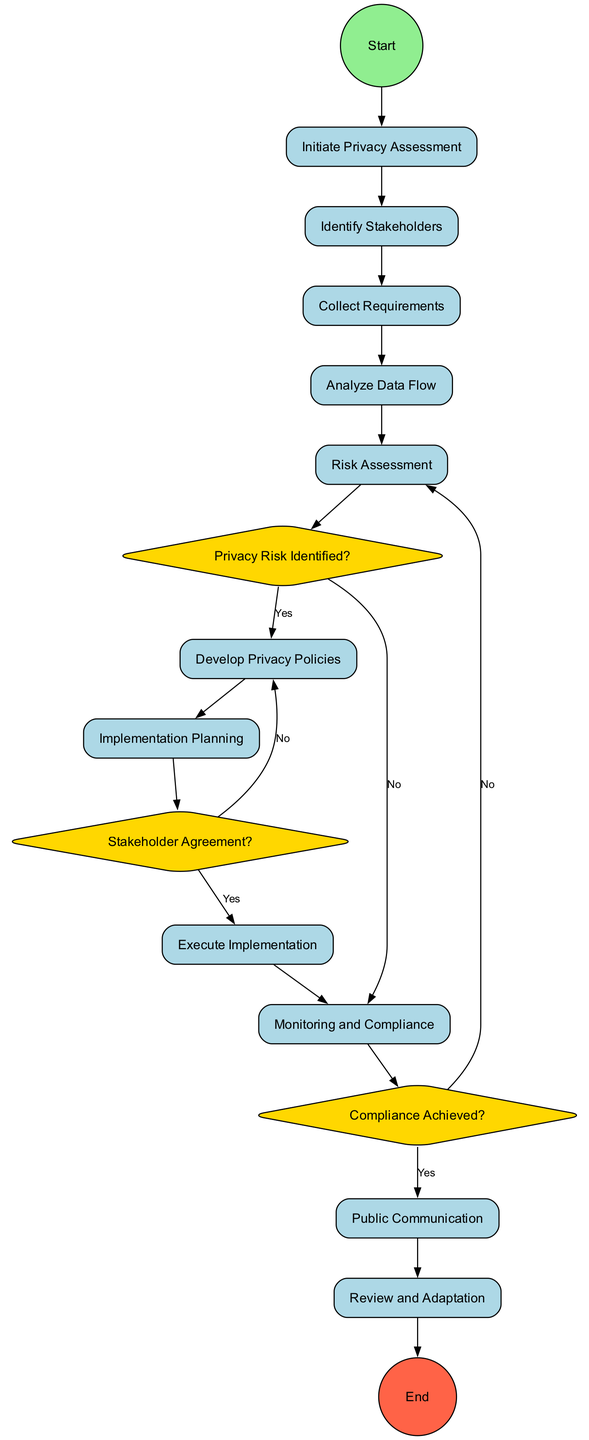What is the starting action in the diagram? The starting action is explicitly indicated by the connection from the start node to the first action node. In this case, it leads to "Initiate Privacy Assessment."
Answer: Initiate Privacy Assessment How many decision nodes are present in the diagram? By counting the nodes shaped as diamonds, we find there are three decision nodes: "Privacy Risk Identified?", "Stakeholder Agreement?", and "Compliance Achieved?".
Answer: 3 What action follows the "Risk Assessment" step if a privacy risk is identified? The diagram connects the "Risk Assessment" node to the "Privacy Risk Identified?" decision node, and if a risk is identified (marked as "Yes"), it leads to the action "Develop Privacy Policies."
Answer: Develop Privacy Policies Which action occurs after "Monitoring and Compliance"? The diagram shows that "Monitoring and Compliance" leads to "Compliance Achieved?", followed by a "Yes" path to "Public Communication."
Answer: Public Communication What happens if no stakeholder agreement is reached? In the case of "Stakeholder Agreement?" if the answer is "No", the flow returns to "Develop Privacy Policies" for further refinement.
Answer: Develop Privacy Policies What are the end nodes in the diagram? The end of the diagram is specified with a connection from the last action "Review and Adaptation" to the end node. The diagram clearly indicates that "Review and Adaptation" leads to the end.
Answer: Review and Adaptation Describe the action taken if a significant privacy risk is identified. The flow indicates that if a significant privacy risk is identified (a "Yes" from the decision node), we proceed to the action "Develop Privacy Policies" which is aimed at creating new privacy guidelines.
Answer: Develop Privacy Policies How does the diagram ensure compliance? Compliance is ensured through the "Monitoring and Compliance" node which connects to "Compliance Achieved?". If compliance is achieved ("Yes"), it moves to "Public Communication".
Answer: Public Communication 